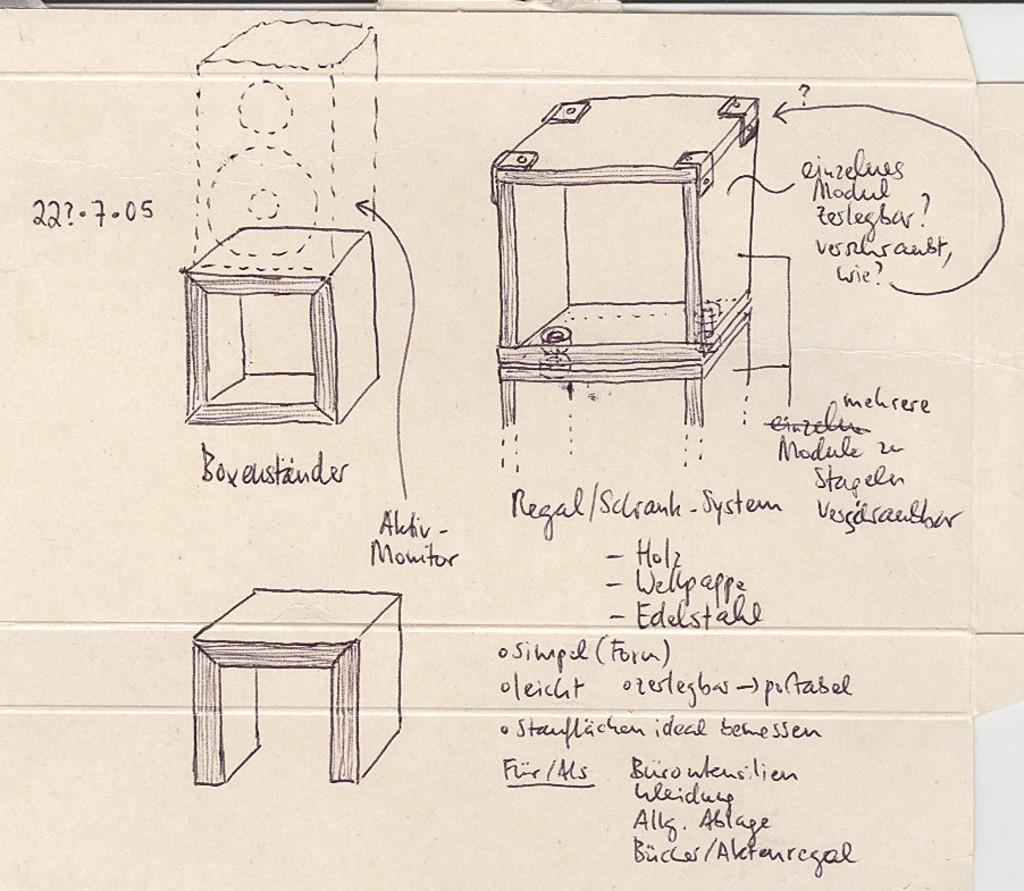What is present in the image that has drawings and written matter? There is a poster in the image that has drawings and written matter. Can you describe the drawings on the poster? Unfortunately, the specific details of the drawings cannot be determined from the provided facts. What type of written matter is on the poster? The type of written matter on the poster cannot be determined from the provided facts. What type of receipt can be seen on the poster in the image? There is no receipt present on the poster in the image. 